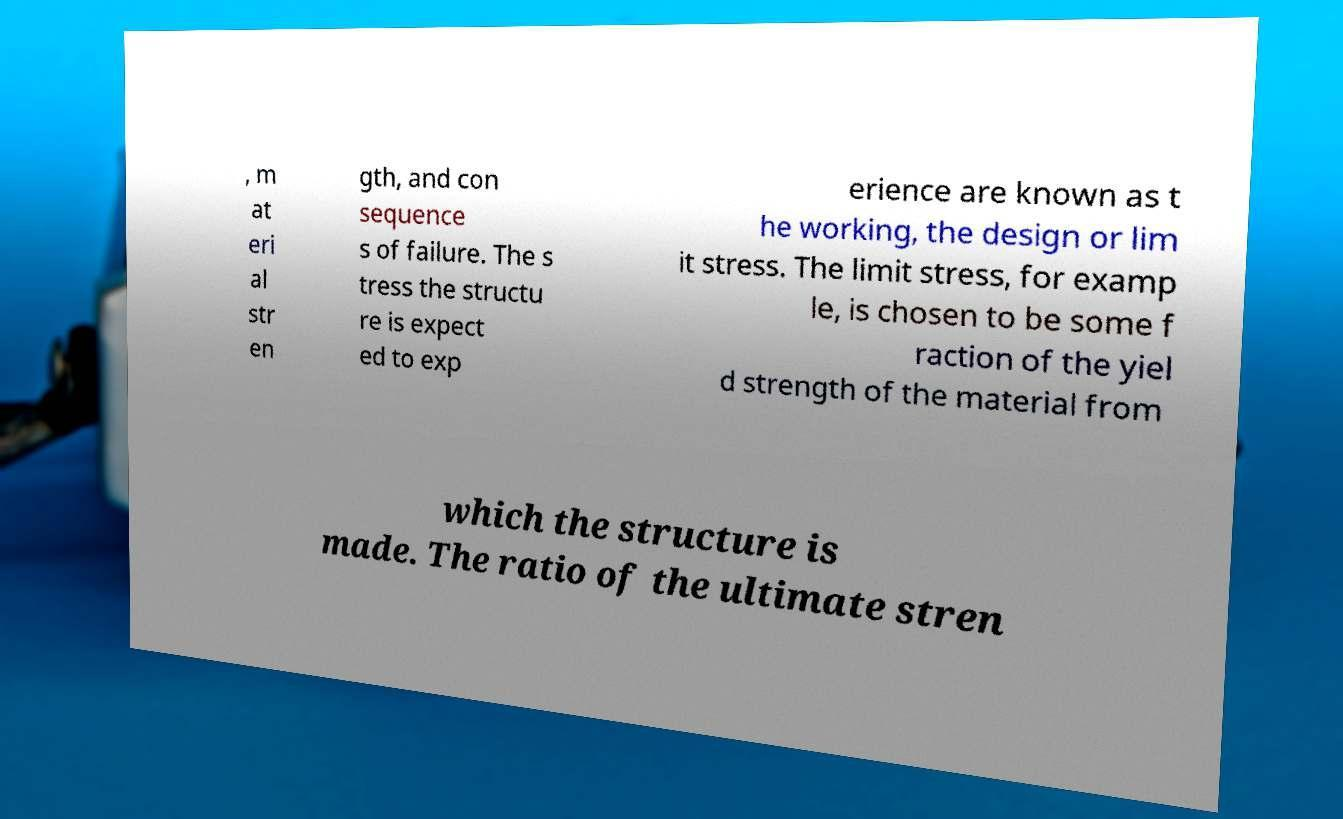There's text embedded in this image that I need extracted. Can you transcribe it verbatim? , m at eri al str en gth, and con sequence s of failure. The s tress the structu re is expect ed to exp erience are known as t he working, the design or lim it stress. The limit stress, for examp le, is chosen to be some f raction of the yiel d strength of the material from which the structure is made. The ratio of the ultimate stren 